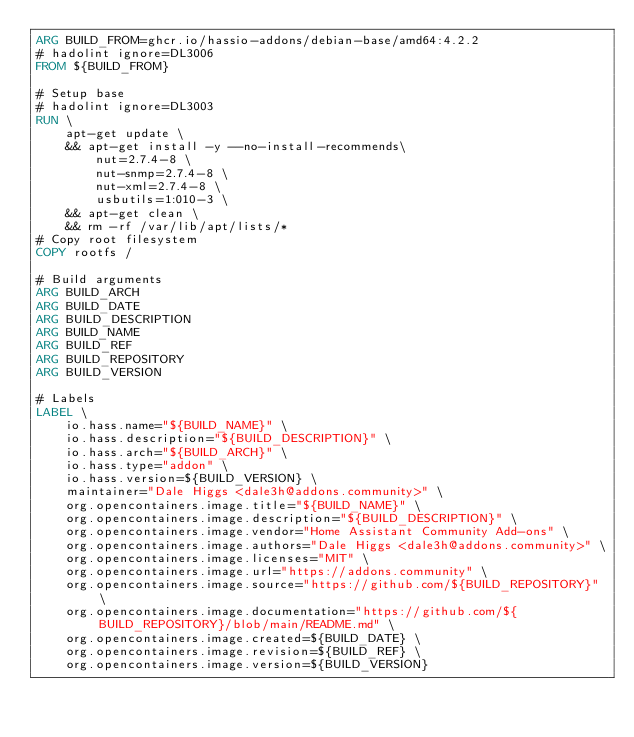<code> <loc_0><loc_0><loc_500><loc_500><_Dockerfile_>ARG BUILD_FROM=ghcr.io/hassio-addons/debian-base/amd64:4.2.2
# hadolint ignore=DL3006
FROM ${BUILD_FROM}

# Setup base
# hadolint ignore=DL3003
RUN \
    apt-get update \
    && apt-get install -y --no-install-recommends\
        nut=2.7.4-8 \
        nut-snmp=2.7.4-8 \
        nut-xml=2.7.4-8 \
        usbutils=1:010-3 \
    && apt-get clean \
    && rm -rf /var/lib/apt/lists/*
# Copy root filesystem
COPY rootfs /

# Build arguments
ARG BUILD_ARCH
ARG BUILD_DATE
ARG BUILD_DESCRIPTION
ARG BUILD_NAME
ARG BUILD_REF
ARG BUILD_REPOSITORY
ARG BUILD_VERSION

# Labels
LABEL \
    io.hass.name="${BUILD_NAME}" \
    io.hass.description="${BUILD_DESCRIPTION}" \
    io.hass.arch="${BUILD_ARCH}" \
    io.hass.type="addon" \
    io.hass.version=${BUILD_VERSION} \
    maintainer="Dale Higgs <dale3h@addons.community>" \
    org.opencontainers.image.title="${BUILD_NAME}" \
    org.opencontainers.image.description="${BUILD_DESCRIPTION}" \
    org.opencontainers.image.vendor="Home Assistant Community Add-ons" \
    org.opencontainers.image.authors="Dale Higgs <dale3h@addons.community>" \
    org.opencontainers.image.licenses="MIT" \
    org.opencontainers.image.url="https://addons.community" \
    org.opencontainers.image.source="https://github.com/${BUILD_REPOSITORY}" \
    org.opencontainers.image.documentation="https://github.com/${BUILD_REPOSITORY}/blob/main/README.md" \
    org.opencontainers.image.created=${BUILD_DATE} \
    org.opencontainers.image.revision=${BUILD_REF} \
    org.opencontainers.image.version=${BUILD_VERSION}
</code> 